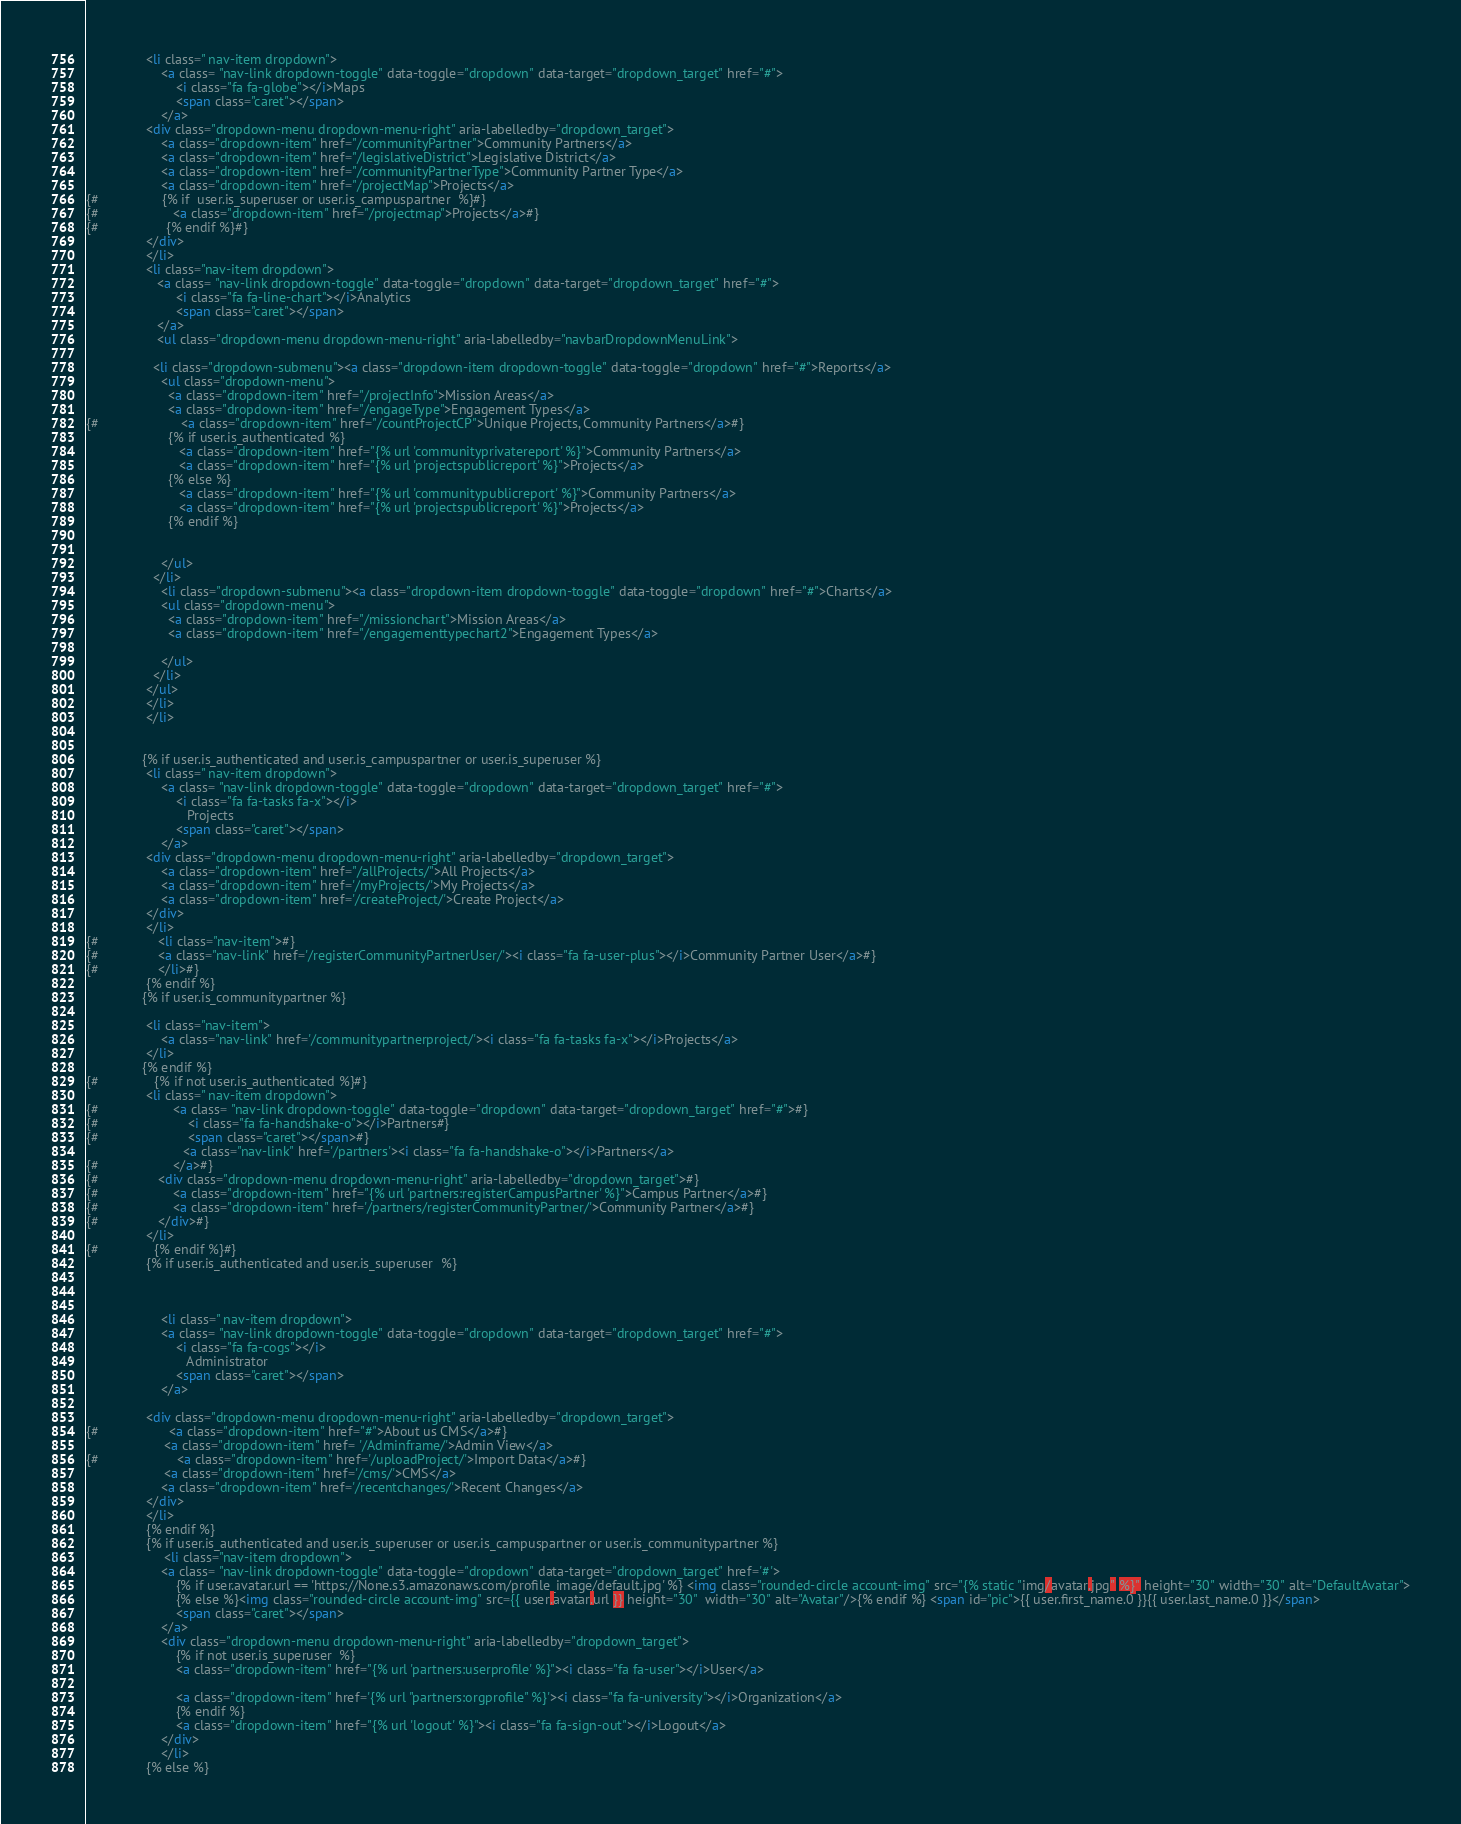Convert code to text. <code><loc_0><loc_0><loc_500><loc_500><_HTML_>                <li class=" nav-item dropdown">
                    <a class= "nav-link dropdown-toggle" data-toggle="dropdown" data-target="dropdown_target" href="#">
                        <i class="fa fa-globe"></i>Maps
                        <span class="caret"></span>
                    </a>
                <div class="dropdown-menu dropdown-menu-right" aria-labelledby="dropdown_target">
                    <a class="dropdown-item" href="/communityPartner">Community Partners</a>
                    <a class="dropdown-item" href="/legislativeDistrict">Legislative District</a>
                    <a class="dropdown-item" href="/communityPartnerType">Community Partner Type</a>
                    <a class="dropdown-item" href="/projectMap">Projects</a>
{#                 {% if  user.is_superuser or user.is_campuspartner  %}#}
{#                    <a class="dropdown-item" href="/projectmap">Projects</a>#}
{#                  {% endif %}#}
                </div>
                </li>
                <li class="nav-item dropdown">
                   <a class= "nav-link dropdown-toggle" data-toggle="dropdown" data-target="dropdown_target" href="#">
                        <i class="fa fa-line-chart"></i>Analytics
                        <span class="caret"></span>
                   </a>
                   <ul class="dropdown-menu dropdown-menu-right" aria-labelledby="navbarDropdownMenuLink">

                  <li class="dropdown-submenu"><a class="dropdown-item dropdown-toggle" data-toggle="dropdown" href="#">Reports</a>
                    <ul class="dropdown-menu">
                      <a class="dropdown-item" href="/projectInfo">Mission Areas</a>
                      <a class="dropdown-item" href="/engageType">Engagement Types</a>
{#                      <a class="dropdown-item" href="/countProjectCP">Unique Projects, Community Partners</a>#}
                      {% if user.is_authenticated %}
                         <a class="dropdown-item" href="{% url 'communityprivatereport' %}">Community Partners</a>
                         <a class="dropdown-item" href="{% url 'projectspublicreport' %}">Projects</a>
                      {% else %}
                         <a class="dropdown-item" href="{% url 'communitypublicreport' %}">Community Partners</a>
                         <a class="dropdown-item" href="{% url 'projectspublicreport' %}">Projects</a>
                      {% endif %}


                    </ul>
                  </li>
                    <li class="dropdown-submenu"><a class="dropdown-item dropdown-toggle" data-toggle="dropdown" href="#">Charts</a>
                    <ul class="dropdown-menu">
                      <a class="dropdown-item" href="/missionchart">Mission Areas</a>
                      <a class="dropdown-item" href="/engagementtypechart2">Engagement Types</a>

                    </ul>
                  </li>
                </ul>
                </li>
                </li>


               {% if user.is_authenticated and user.is_campuspartner or user.is_superuser %}
                <li class=" nav-item dropdown">
                    <a class= "nav-link dropdown-toggle" data-toggle="dropdown" data-target="dropdown_target" href="#">
                        <i class="fa fa-tasks fa-x"></i>
                           Projects
                        <span class="caret"></span>
                    </a>
                <div class="dropdown-menu dropdown-menu-right" aria-labelledby="dropdown_target">
                    <a class="dropdown-item" href="/allProjects/">All Projects</a>
                    <a class="dropdown-item" href='/myProjects/'>My Projects</a>
                    <a class="dropdown-item" href='/createProject/'>Create Project</a>
                </div>
                </li>
{#                <li class="nav-item">#}
{#                <a class="nav-link" href='/registerCommunityPartnerUser/'><i class="fa fa-user-plus"></i>Community Partner User</a>#}
{#                </li>#}
                {% endif %}
               {% if user.is_communitypartner %}

                <li class="nav-item">
                    <a class="nav-link" href='/communitypartnerproject/'><i class="fa fa-tasks fa-x"></i>Projects</a>
                </li>
               {% endif %}
{#               {% if not user.is_authenticated %}#}
                <li class=" nav-item dropdown">
{#                    <a class= "nav-link dropdown-toggle" data-toggle="dropdown" data-target="dropdown_target" href="#">#}
{#                        <i class="fa fa-handshake-o"></i>Partners#}
{#                        <span class="caret"></span>#}
                          <a class="nav-link" href='/partners'><i class="fa fa-handshake-o"></i>Partners</a>
{#                    </a>#}
{#                <div class="dropdown-menu dropdown-menu-right" aria-labelledby="dropdown_target">#}
{#                    <a class="dropdown-item" href="{% url 'partners:registerCampusPartner' %}">Campus Partner</a>#}
{#                    <a class="dropdown-item" href='/partners/registerCommunityPartner/'>Community Partner</a>#}
{#                </div>#}
                </li>
{#               {% endif %}#}
                {% if user.is_authenticated and user.is_superuser  %}



                    <li class=" nav-item dropdown">
                    <a class= "nav-link dropdown-toggle" data-toggle="dropdown" data-target="dropdown_target" href="#">
                        <i class="fa fa-cogs"></i>
                           Administrator
                        <span class="caret"></span>
                    </a>

                <div class="dropdown-menu dropdown-menu-right" aria-labelledby="dropdown_target">
{#                   <a class="dropdown-item" href="#">About us CMS</a>#}
                     <a class="dropdown-item" href= '/Adminframe/'>Admin View</a>
{#                     <a class="dropdown-item" href='/uploadProject/'>Import Data</a>#}
                     <a class="dropdown-item" href='/cms/'>CMS</a>
                    <a class="dropdown-item" href='/recentchanges/'>Recent Changes</a>
                </div>
                </li>
                {% endif %}
                {% if user.is_authenticated and user.is_superuser or user.is_campuspartner or user.is_communitypartner %}
                     <li class="nav-item dropdown">
                    <a class= "nav-link dropdown-toggle" data-toggle="dropdown" data-target="dropdown_target" href='#'>
                        {% if user.avatar.url == 'https://None.s3.amazonaws.com/profile_image/default.jpg' %} <img class="rounded-circle account-img" src="{% static "img/avatar.jpg" %}" height="30" width="30" alt="DefaultAvatar">
                        {% else %}<img class="rounded-circle account-img" src={{ user.avatar.url }} height="30"  width="30" alt="Avatar"/>{% endif %} <span id="pic">{{ user.first_name.0 }}{{ user.last_name.0 }}</span>
                        <span class="caret"></span>
                    </a>
                    <div class="dropdown-menu dropdown-menu-right" aria-labelledby="dropdown_target">
                        {% if not user.is_superuser  %}
                        <a class="dropdown-item" href="{% url 'partners:userprofile' %}"><i class="fa fa-user"></i>User</a>

                        <a class="dropdown-item" href='{% url "partners:orgprofile" %}'><i class="fa fa-university"></i>Organization</a>
                        {% endif %}
                        <a class="dropdown-item" href="{% url 'logout' %}"><i class="fa fa-sign-out"></i>Logout</a>
                    </div>
                    </li>
                {% else %}</code> 